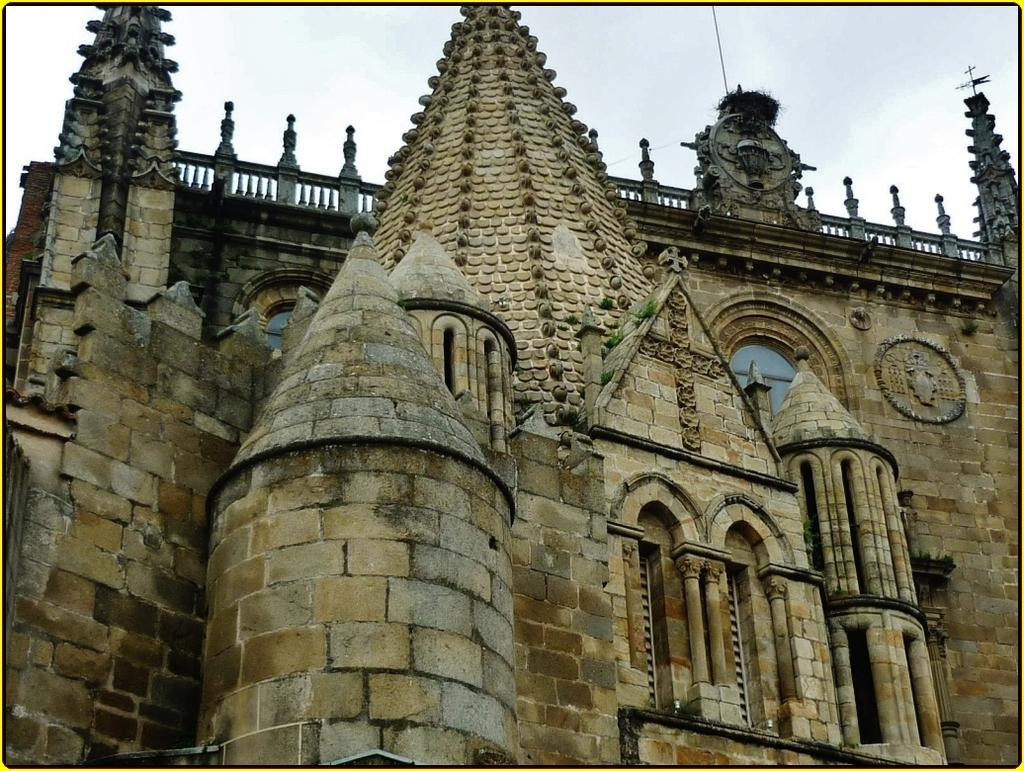What type of structure is present in the image? There is a building in the image. What colors can be seen on the building? The building has cream, brown, and black colors. What can be seen in the background of the image? The sky is visible in the background of the image. What role does the father play in the image? There is no father present in the image; it only features a building and the sky. Can you tell me what the minister is doing in the image? There is no minister present in the image; it only features a building and the sky. 